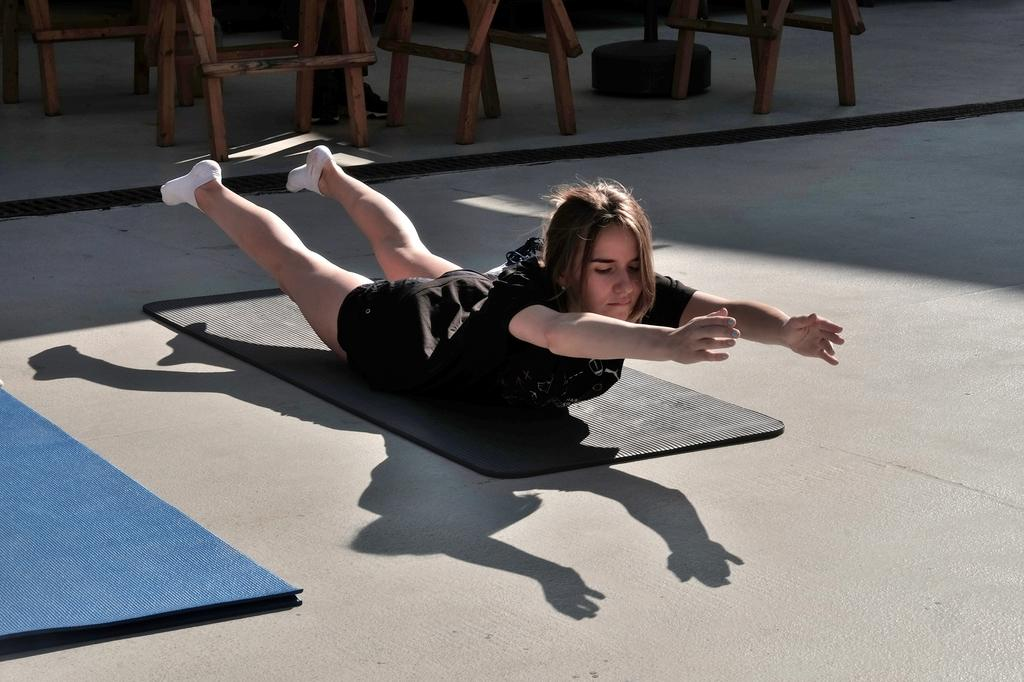Who is the main subject in the image? There is a lady in the image. What is the lady wearing? The lady is wearing a black dress. What is the lady lying on? The lady is lying on a black mat. What color is the mat next to the black mat? There is a blue mat next to the black mat. What can be seen in the background of the image? There are chairs visible in the background of the image. How many bats are flying around the lady in the image? There are no bats present in the image. What is the amount of ice cream the lady is holding in the image? The lady is not holding any ice cream in the image. 